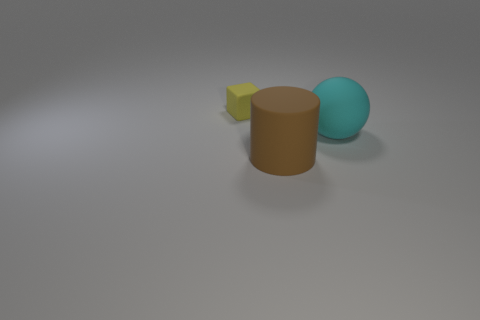Are there any other things that are the same size as the yellow object?
Provide a succinct answer. No. Are there any other things that have the same shape as the brown rubber thing?
Make the answer very short. No. Are there more blocks than yellow metal things?
Keep it short and to the point. Yes. The large thing that is in front of the big thing that is to the right of the big matte cylinder that is in front of the large sphere is made of what material?
Offer a very short reply. Rubber. The brown thing that is the same size as the ball is what shape?
Make the answer very short. Cylinder. Are there fewer matte spheres than matte things?
Keep it short and to the point. Yes. How many cubes have the same size as the cylinder?
Your answer should be very brief. 0. How big is the object that is in front of the large cyan rubber ball?
Make the answer very short. Large. What shape is the cyan thing that is the same material as the big brown cylinder?
Give a very brief answer. Sphere. How many purple things are cylinders or rubber objects?
Provide a succinct answer. 0. 